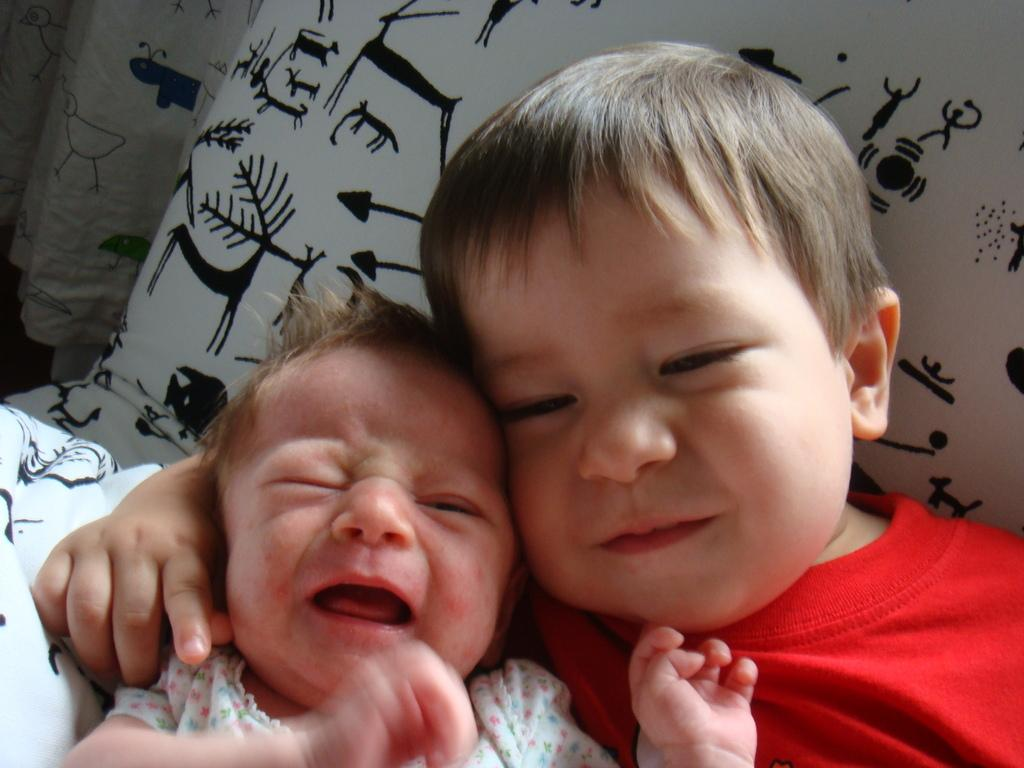Who is the main subject in the image? The main subject in the image is a small boy. What is the boy wearing? The boy is wearing a red t-shirt. What is the boy lying on? The boy is lying on a white color pillow. Are there any other children in the image? Yes, there is a small baby in the image. How is the baby feeling? The baby is crying. Reasoning: Let's think step by step by following the given facts step by step to produce the conversation. We start by identifying the main subject, which is the small boy. Then, we describe his clothing and the object he is lying on. Next, we mention the presence of another child, the small baby, and describe the baby's emotional state. Each question is designed to elicit a specific detail about the image that is known from the provided facts. Absurd Question/Answer: What time does the word "limit" appear in the image? There is no mention of time or the word "limit" in the image. 